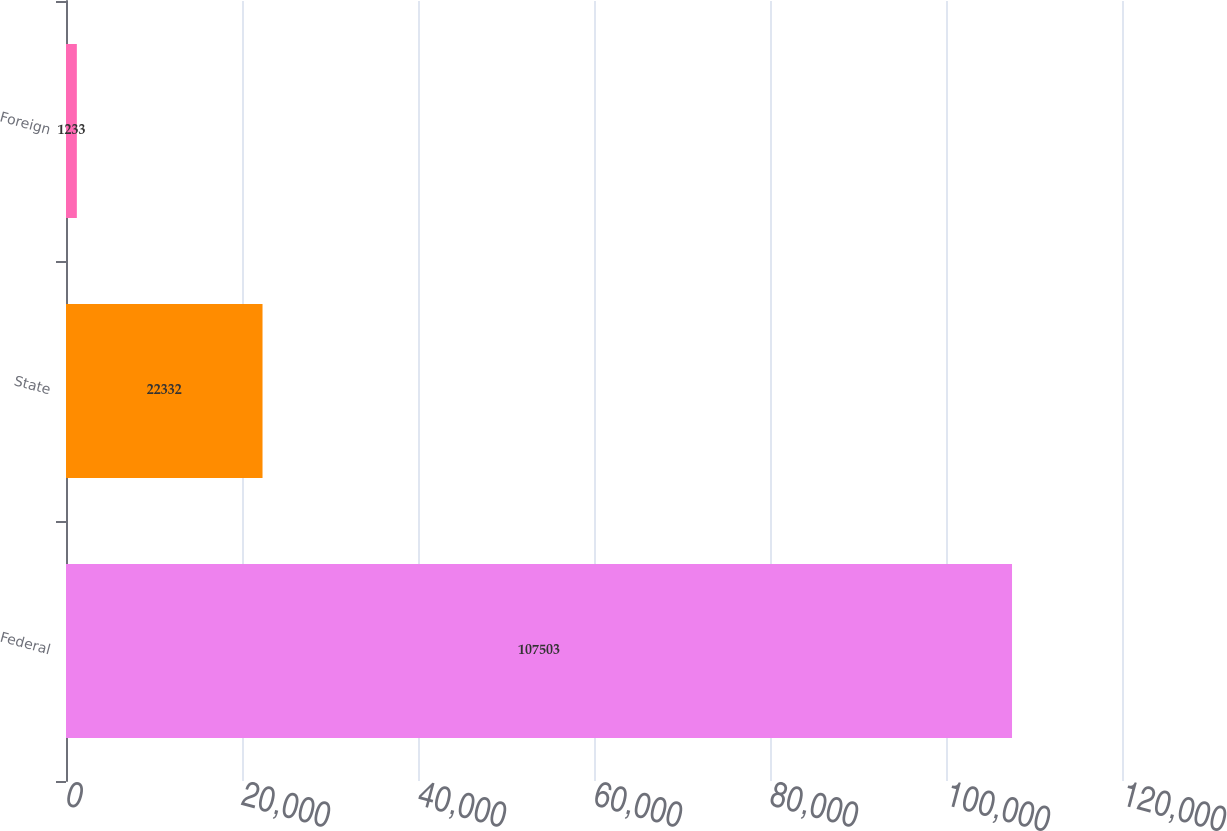Convert chart. <chart><loc_0><loc_0><loc_500><loc_500><bar_chart><fcel>Federal<fcel>State<fcel>Foreign<nl><fcel>107503<fcel>22332<fcel>1233<nl></chart> 